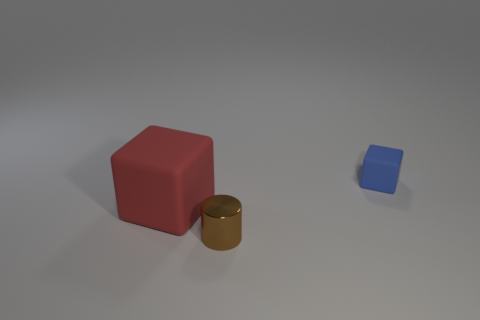Add 1 red blocks. How many objects exist? 4 Subtract all cylinders. How many objects are left? 2 Add 1 large blocks. How many large blocks exist? 2 Subtract 1 brown cylinders. How many objects are left? 2 Subtract all large gray metal cylinders. Subtract all tiny things. How many objects are left? 1 Add 2 blue blocks. How many blue blocks are left? 3 